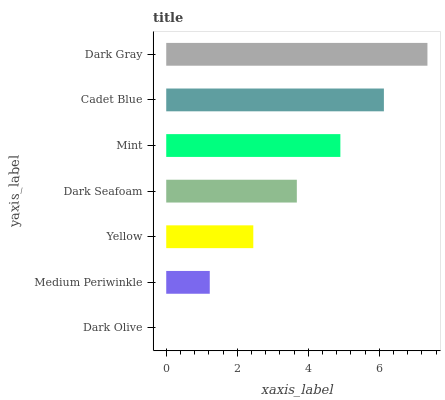Is Dark Olive the minimum?
Answer yes or no. Yes. Is Dark Gray the maximum?
Answer yes or no. Yes. Is Medium Periwinkle the minimum?
Answer yes or no. No. Is Medium Periwinkle the maximum?
Answer yes or no. No. Is Medium Periwinkle greater than Dark Olive?
Answer yes or no. Yes. Is Dark Olive less than Medium Periwinkle?
Answer yes or no. Yes. Is Dark Olive greater than Medium Periwinkle?
Answer yes or no. No. Is Medium Periwinkle less than Dark Olive?
Answer yes or no. No. Is Dark Seafoam the high median?
Answer yes or no. Yes. Is Dark Seafoam the low median?
Answer yes or no. Yes. Is Dark Olive the high median?
Answer yes or no. No. Is Dark Olive the low median?
Answer yes or no. No. 